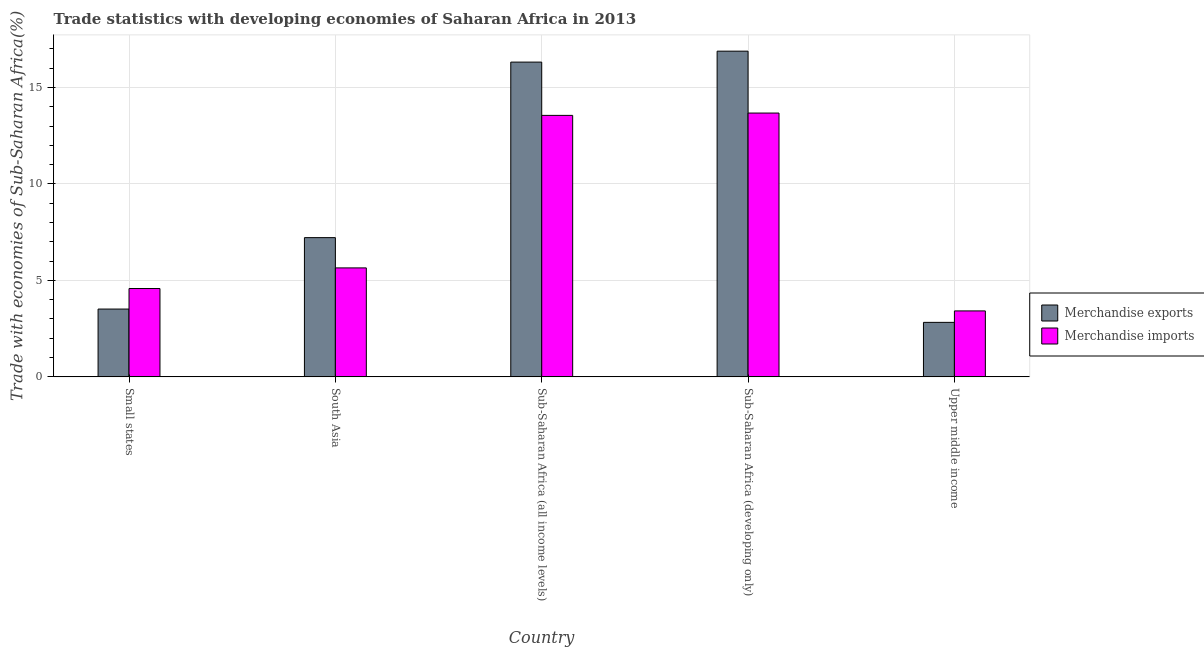How many groups of bars are there?
Keep it short and to the point. 5. What is the label of the 5th group of bars from the left?
Keep it short and to the point. Upper middle income. In how many cases, is the number of bars for a given country not equal to the number of legend labels?
Give a very brief answer. 0. What is the merchandise imports in South Asia?
Your answer should be very brief. 5.65. Across all countries, what is the maximum merchandise imports?
Provide a succinct answer. 13.67. Across all countries, what is the minimum merchandise imports?
Ensure brevity in your answer.  3.42. In which country was the merchandise exports maximum?
Your response must be concise. Sub-Saharan Africa (developing only). In which country was the merchandise exports minimum?
Provide a short and direct response. Upper middle income. What is the total merchandise imports in the graph?
Your answer should be very brief. 40.87. What is the difference between the merchandise imports in Small states and that in Sub-Saharan Africa (developing only)?
Ensure brevity in your answer.  -9.09. What is the difference between the merchandise exports in Small states and the merchandise imports in Sub-Saharan Africa (developing only)?
Give a very brief answer. -10.16. What is the average merchandise imports per country?
Make the answer very short. 8.17. What is the difference between the merchandise imports and merchandise exports in South Asia?
Keep it short and to the point. -1.57. What is the ratio of the merchandise imports in South Asia to that in Sub-Saharan Africa (all income levels)?
Ensure brevity in your answer.  0.42. Is the difference between the merchandise imports in South Asia and Upper middle income greater than the difference between the merchandise exports in South Asia and Upper middle income?
Provide a short and direct response. No. What is the difference between the highest and the second highest merchandise exports?
Provide a short and direct response. 0.57. What is the difference between the highest and the lowest merchandise imports?
Offer a terse response. 10.26. In how many countries, is the merchandise exports greater than the average merchandise exports taken over all countries?
Provide a succinct answer. 2. Is the sum of the merchandise exports in South Asia and Sub-Saharan Africa (all income levels) greater than the maximum merchandise imports across all countries?
Offer a terse response. Yes. What does the 1st bar from the right in South Asia represents?
Your answer should be very brief. Merchandise imports. How many bars are there?
Provide a short and direct response. 10. Are all the bars in the graph horizontal?
Make the answer very short. No. How many countries are there in the graph?
Give a very brief answer. 5. What is the difference between two consecutive major ticks on the Y-axis?
Your answer should be very brief. 5. Does the graph contain any zero values?
Provide a succinct answer. No. Does the graph contain grids?
Give a very brief answer. Yes. What is the title of the graph?
Keep it short and to the point. Trade statistics with developing economies of Saharan Africa in 2013. What is the label or title of the Y-axis?
Offer a very short reply. Trade with economies of Sub-Saharan Africa(%). What is the Trade with economies of Sub-Saharan Africa(%) in Merchandise exports in Small states?
Offer a very short reply. 3.52. What is the Trade with economies of Sub-Saharan Africa(%) in Merchandise imports in Small states?
Make the answer very short. 4.58. What is the Trade with economies of Sub-Saharan Africa(%) in Merchandise exports in South Asia?
Your response must be concise. 7.22. What is the Trade with economies of Sub-Saharan Africa(%) in Merchandise imports in South Asia?
Offer a very short reply. 5.65. What is the Trade with economies of Sub-Saharan Africa(%) in Merchandise exports in Sub-Saharan Africa (all income levels)?
Give a very brief answer. 16.32. What is the Trade with economies of Sub-Saharan Africa(%) in Merchandise imports in Sub-Saharan Africa (all income levels)?
Your answer should be compact. 13.55. What is the Trade with economies of Sub-Saharan Africa(%) of Merchandise exports in Sub-Saharan Africa (developing only)?
Your answer should be very brief. 16.88. What is the Trade with economies of Sub-Saharan Africa(%) in Merchandise imports in Sub-Saharan Africa (developing only)?
Give a very brief answer. 13.67. What is the Trade with economies of Sub-Saharan Africa(%) in Merchandise exports in Upper middle income?
Your response must be concise. 2.83. What is the Trade with economies of Sub-Saharan Africa(%) of Merchandise imports in Upper middle income?
Provide a succinct answer. 3.42. Across all countries, what is the maximum Trade with economies of Sub-Saharan Africa(%) in Merchandise exports?
Offer a very short reply. 16.88. Across all countries, what is the maximum Trade with economies of Sub-Saharan Africa(%) in Merchandise imports?
Ensure brevity in your answer.  13.67. Across all countries, what is the minimum Trade with economies of Sub-Saharan Africa(%) in Merchandise exports?
Offer a very short reply. 2.83. Across all countries, what is the minimum Trade with economies of Sub-Saharan Africa(%) of Merchandise imports?
Your response must be concise. 3.42. What is the total Trade with economies of Sub-Saharan Africa(%) of Merchandise exports in the graph?
Provide a succinct answer. 46.75. What is the total Trade with economies of Sub-Saharan Africa(%) in Merchandise imports in the graph?
Ensure brevity in your answer.  40.87. What is the difference between the Trade with economies of Sub-Saharan Africa(%) of Merchandise exports in Small states and that in South Asia?
Provide a short and direct response. -3.7. What is the difference between the Trade with economies of Sub-Saharan Africa(%) of Merchandise imports in Small states and that in South Asia?
Ensure brevity in your answer.  -1.07. What is the difference between the Trade with economies of Sub-Saharan Africa(%) in Merchandise exports in Small states and that in Sub-Saharan Africa (all income levels)?
Ensure brevity in your answer.  -12.8. What is the difference between the Trade with economies of Sub-Saharan Africa(%) in Merchandise imports in Small states and that in Sub-Saharan Africa (all income levels)?
Provide a short and direct response. -8.97. What is the difference between the Trade with economies of Sub-Saharan Africa(%) in Merchandise exports in Small states and that in Sub-Saharan Africa (developing only)?
Offer a terse response. -13.37. What is the difference between the Trade with economies of Sub-Saharan Africa(%) of Merchandise imports in Small states and that in Sub-Saharan Africa (developing only)?
Provide a short and direct response. -9.09. What is the difference between the Trade with economies of Sub-Saharan Africa(%) of Merchandise exports in Small states and that in Upper middle income?
Your answer should be very brief. 0.69. What is the difference between the Trade with economies of Sub-Saharan Africa(%) in Merchandise imports in Small states and that in Upper middle income?
Ensure brevity in your answer.  1.16. What is the difference between the Trade with economies of Sub-Saharan Africa(%) in Merchandise exports in South Asia and that in Sub-Saharan Africa (all income levels)?
Ensure brevity in your answer.  -9.1. What is the difference between the Trade with economies of Sub-Saharan Africa(%) in Merchandise imports in South Asia and that in Sub-Saharan Africa (all income levels)?
Your answer should be very brief. -7.91. What is the difference between the Trade with economies of Sub-Saharan Africa(%) of Merchandise exports in South Asia and that in Sub-Saharan Africa (developing only)?
Offer a very short reply. -9.67. What is the difference between the Trade with economies of Sub-Saharan Africa(%) in Merchandise imports in South Asia and that in Sub-Saharan Africa (developing only)?
Offer a very short reply. -8.03. What is the difference between the Trade with economies of Sub-Saharan Africa(%) of Merchandise exports in South Asia and that in Upper middle income?
Give a very brief answer. 4.39. What is the difference between the Trade with economies of Sub-Saharan Africa(%) of Merchandise imports in South Asia and that in Upper middle income?
Provide a succinct answer. 2.23. What is the difference between the Trade with economies of Sub-Saharan Africa(%) in Merchandise exports in Sub-Saharan Africa (all income levels) and that in Sub-Saharan Africa (developing only)?
Provide a short and direct response. -0.57. What is the difference between the Trade with economies of Sub-Saharan Africa(%) in Merchandise imports in Sub-Saharan Africa (all income levels) and that in Sub-Saharan Africa (developing only)?
Your answer should be compact. -0.12. What is the difference between the Trade with economies of Sub-Saharan Africa(%) of Merchandise exports in Sub-Saharan Africa (all income levels) and that in Upper middle income?
Offer a very short reply. 13.49. What is the difference between the Trade with economies of Sub-Saharan Africa(%) in Merchandise imports in Sub-Saharan Africa (all income levels) and that in Upper middle income?
Offer a very short reply. 10.13. What is the difference between the Trade with economies of Sub-Saharan Africa(%) of Merchandise exports in Sub-Saharan Africa (developing only) and that in Upper middle income?
Provide a short and direct response. 14.06. What is the difference between the Trade with economies of Sub-Saharan Africa(%) in Merchandise imports in Sub-Saharan Africa (developing only) and that in Upper middle income?
Offer a terse response. 10.26. What is the difference between the Trade with economies of Sub-Saharan Africa(%) in Merchandise exports in Small states and the Trade with economies of Sub-Saharan Africa(%) in Merchandise imports in South Asia?
Your response must be concise. -2.13. What is the difference between the Trade with economies of Sub-Saharan Africa(%) of Merchandise exports in Small states and the Trade with economies of Sub-Saharan Africa(%) of Merchandise imports in Sub-Saharan Africa (all income levels)?
Your answer should be very brief. -10.04. What is the difference between the Trade with economies of Sub-Saharan Africa(%) of Merchandise exports in Small states and the Trade with economies of Sub-Saharan Africa(%) of Merchandise imports in Sub-Saharan Africa (developing only)?
Offer a very short reply. -10.16. What is the difference between the Trade with economies of Sub-Saharan Africa(%) of Merchandise exports in Small states and the Trade with economies of Sub-Saharan Africa(%) of Merchandise imports in Upper middle income?
Provide a short and direct response. 0.1. What is the difference between the Trade with economies of Sub-Saharan Africa(%) in Merchandise exports in South Asia and the Trade with economies of Sub-Saharan Africa(%) in Merchandise imports in Sub-Saharan Africa (all income levels)?
Give a very brief answer. -6.34. What is the difference between the Trade with economies of Sub-Saharan Africa(%) of Merchandise exports in South Asia and the Trade with economies of Sub-Saharan Africa(%) of Merchandise imports in Sub-Saharan Africa (developing only)?
Provide a short and direct response. -6.46. What is the difference between the Trade with economies of Sub-Saharan Africa(%) in Merchandise exports in South Asia and the Trade with economies of Sub-Saharan Africa(%) in Merchandise imports in Upper middle income?
Offer a terse response. 3.8. What is the difference between the Trade with economies of Sub-Saharan Africa(%) in Merchandise exports in Sub-Saharan Africa (all income levels) and the Trade with economies of Sub-Saharan Africa(%) in Merchandise imports in Sub-Saharan Africa (developing only)?
Give a very brief answer. 2.64. What is the difference between the Trade with economies of Sub-Saharan Africa(%) of Merchandise exports in Sub-Saharan Africa (all income levels) and the Trade with economies of Sub-Saharan Africa(%) of Merchandise imports in Upper middle income?
Your answer should be very brief. 12.9. What is the difference between the Trade with economies of Sub-Saharan Africa(%) in Merchandise exports in Sub-Saharan Africa (developing only) and the Trade with economies of Sub-Saharan Africa(%) in Merchandise imports in Upper middle income?
Keep it short and to the point. 13.46. What is the average Trade with economies of Sub-Saharan Africa(%) in Merchandise exports per country?
Your answer should be very brief. 9.35. What is the average Trade with economies of Sub-Saharan Africa(%) in Merchandise imports per country?
Your answer should be compact. 8.17. What is the difference between the Trade with economies of Sub-Saharan Africa(%) of Merchandise exports and Trade with economies of Sub-Saharan Africa(%) of Merchandise imports in Small states?
Your response must be concise. -1.06. What is the difference between the Trade with economies of Sub-Saharan Africa(%) in Merchandise exports and Trade with economies of Sub-Saharan Africa(%) in Merchandise imports in South Asia?
Your answer should be very brief. 1.57. What is the difference between the Trade with economies of Sub-Saharan Africa(%) in Merchandise exports and Trade with economies of Sub-Saharan Africa(%) in Merchandise imports in Sub-Saharan Africa (all income levels)?
Keep it short and to the point. 2.76. What is the difference between the Trade with economies of Sub-Saharan Africa(%) in Merchandise exports and Trade with economies of Sub-Saharan Africa(%) in Merchandise imports in Sub-Saharan Africa (developing only)?
Provide a short and direct response. 3.21. What is the difference between the Trade with economies of Sub-Saharan Africa(%) of Merchandise exports and Trade with economies of Sub-Saharan Africa(%) of Merchandise imports in Upper middle income?
Ensure brevity in your answer.  -0.59. What is the ratio of the Trade with economies of Sub-Saharan Africa(%) in Merchandise exports in Small states to that in South Asia?
Your answer should be very brief. 0.49. What is the ratio of the Trade with economies of Sub-Saharan Africa(%) in Merchandise imports in Small states to that in South Asia?
Make the answer very short. 0.81. What is the ratio of the Trade with economies of Sub-Saharan Africa(%) in Merchandise exports in Small states to that in Sub-Saharan Africa (all income levels)?
Give a very brief answer. 0.22. What is the ratio of the Trade with economies of Sub-Saharan Africa(%) of Merchandise imports in Small states to that in Sub-Saharan Africa (all income levels)?
Give a very brief answer. 0.34. What is the ratio of the Trade with economies of Sub-Saharan Africa(%) in Merchandise exports in Small states to that in Sub-Saharan Africa (developing only)?
Your answer should be compact. 0.21. What is the ratio of the Trade with economies of Sub-Saharan Africa(%) in Merchandise imports in Small states to that in Sub-Saharan Africa (developing only)?
Make the answer very short. 0.33. What is the ratio of the Trade with economies of Sub-Saharan Africa(%) of Merchandise exports in Small states to that in Upper middle income?
Keep it short and to the point. 1.24. What is the ratio of the Trade with economies of Sub-Saharan Africa(%) in Merchandise imports in Small states to that in Upper middle income?
Ensure brevity in your answer.  1.34. What is the ratio of the Trade with economies of Sub-Saharan Africa(%) of Merchandise exports in South Asia to that in Sub-Saharan Africa (all income levels)?
Make the answer very short. 0.44. What is the ratio of the Trade with economies of Sub-Saharan Africa(%) in Merchandise imports in South Asia to that in Sub-Saharan Africa (all income levels)?
Ensure brevity in your answer.  0.42. What is the ratio of the Trade with economies of Sub-Saharan Africa(%) of Merchandise exports in South Asia to that in Sub-Saharan Africa (developing only)?
Make the answer very short. 0.43. What is the ratio of the Trade with economies of Sub-Saharan Africa(%) of Merchandise imports in South Asia to that in Sub-Saharan Africa (developing only)?
Provide a succinct answer. 0.41. What is the ratio of the Trade with economies of Sub-Saharan Africa(%) in Merchandise exports in South Asia to that in Upper middle income?
Make the answer very short. 2.55. What is the ratio of the Trade with economies of Sub-Saharan Africa(%) of Merchandise imports in South Asia to that in Upper middle income?
Offer a terse response. 1.65. What is the ratio of the Trade with economies of Sub-Saharan Africa(%) in Merchandise exports in Sub-Saharan Africa (all income levels) to that in Sub-Saharan Africa (developing only)?
Your response must be concise. 0.97. What is the ratio of the Trade with economies of Sub-Saharan Africa(%) of Merchandise exports in Sub-Saharan Africa (all income levels) to that in Upper middle income?
Ensure brevity in your answer.  5.77. What is the ratio of the Trade with economies of Sub-Saharan Africa(%) of Merchandise imports in Sub-Saharan Africa (all income levels) to that in Upper middle income?
Make the answer very short. 3.96. What is the ratio of the Trade with economies of Sub-Saharan Africa(%) of Merchandise exports in Sub-Saharan Africa (developing only) to that in Upper middle income?
Your answer should be very brief. 5.98. What is the ratio of the Trade with economies of Sub-Saharan Africa(%) in Merchandise imports in Sub-Saharan Africa (developing only) to that in Upper middle income?
Make the answer very short. 4. What is the difference between the highest and the second highest Trade with economies of Sub-Saharan Africa(%) in Merchandise exports?
Provide a succinct answer. 0.57. What is the difference between the highest and the second highest Trade with economies of Sub-Saharan Africa(%) in Merchandise imports?
Keep it short and to the point. 0.12. What is the difference between the highest and the lowest Trade with economies of Sub-Saharan Africa(%) in Merchandise exports?
Ensure brevity in your answer.  14.06. What is the difference between the highest and the lowest Trade with economies of Sub-Saharan Africa(%) in Merchandise imports?
Ensure brevity in your answer.  10.26. 